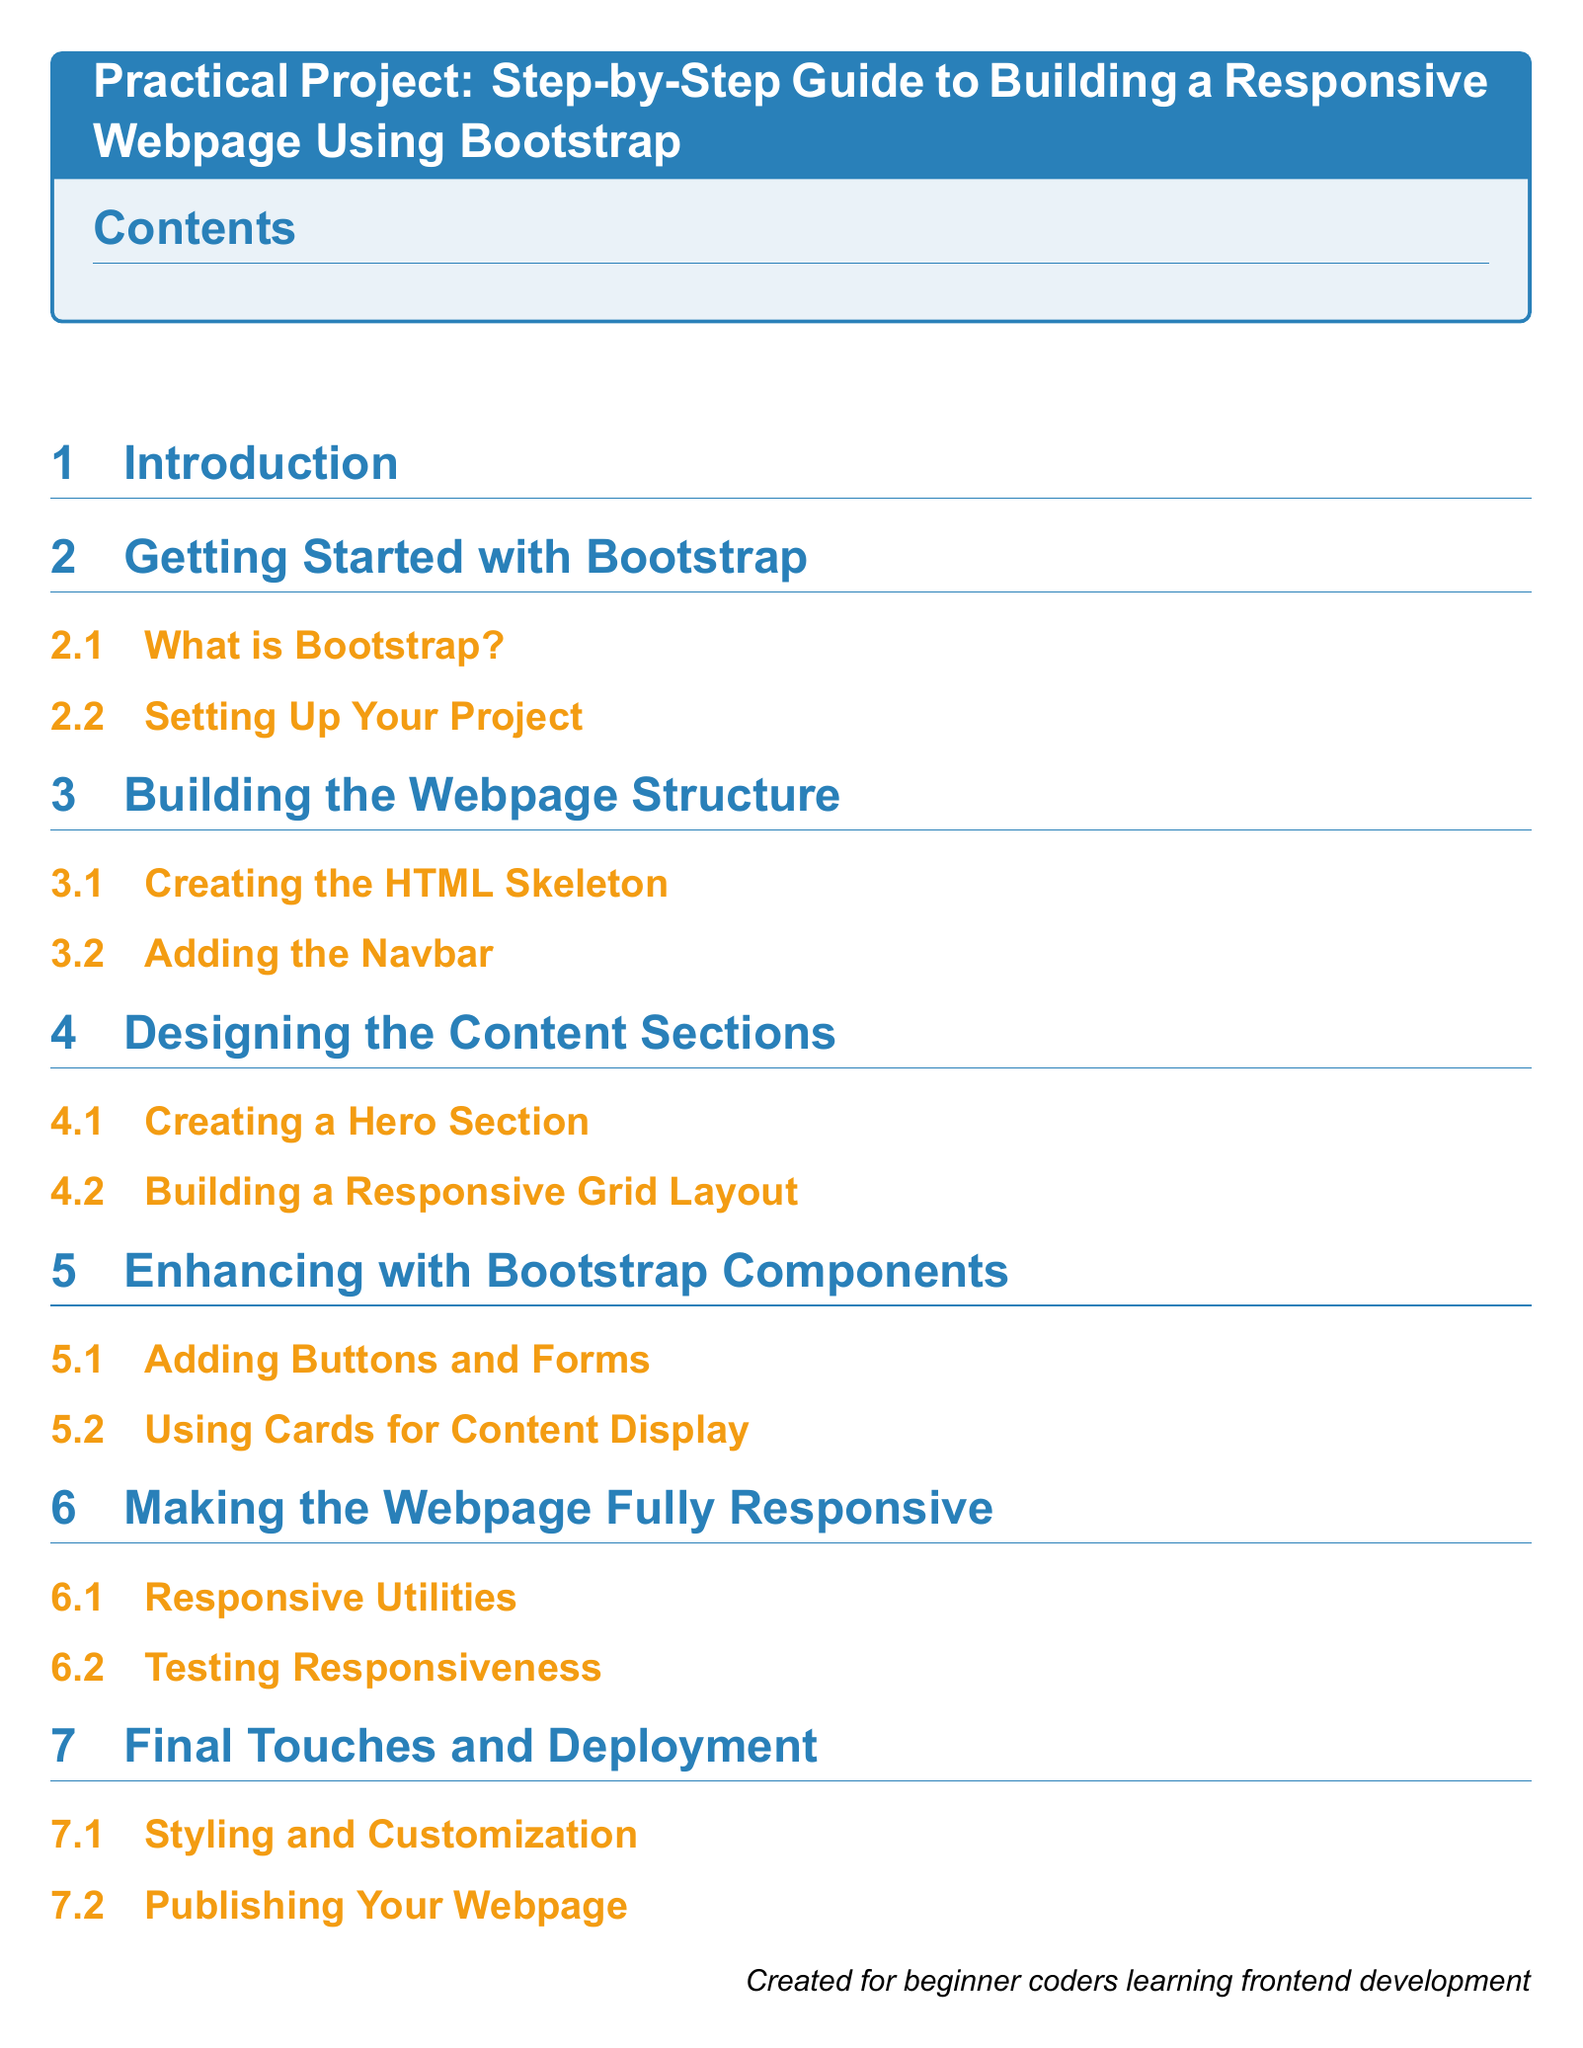What is the title of the document? The title of the document is presented in a large tcolorbox at the beginning, stating the subject of the project.
Answer: Practical Project: Step-by-Step Guide to Building a Responsive Webpage Using Bootstrap How many main sections are there in the document? The document outlines six distinct sections based on the structured headings provided.
Answer: 6 What is the focus of the first subsection under "Getting Started with Bootstrap"? The first subsection elaborates on the basic definition of Bootstrap, providing an introduction to the framework.
Answer: What is Bootstrap? What type of layout is created in the "Designing the Content Sections"? This section focuses on creating a structure that adapts based on the device screen size for optimal presentation.
Answer: Responsive Grid Layout Which Bootstrap component is discussed in the "Enhancing with Bootstrap Components"? The subsection discusses various components provided by Bootstrap that enhance user interaction on a webpage.
Answer: Buttons and Forms What is the purpose of the final section in the document? The last section is dedicated to describing the final steps in refining the webpage and making it publicly accessible.
Answer: Final Touches and Deployment 